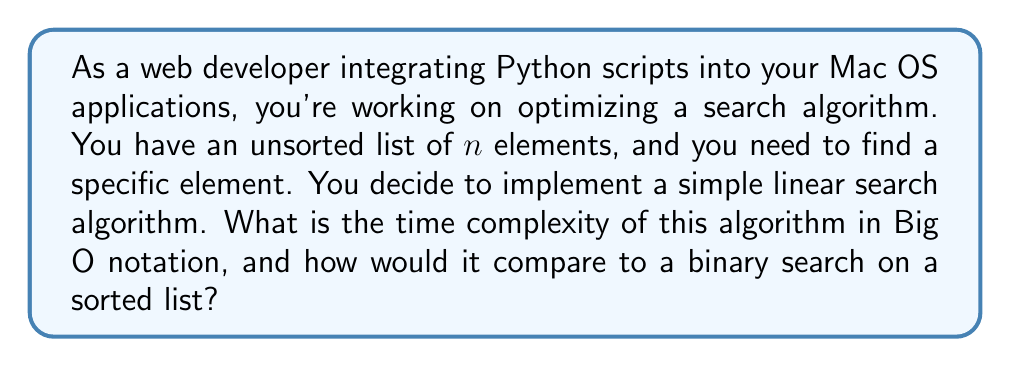Solve this math problem. To determine the time complexity of the linear search algorithm, let's break it down step-by-step:

1. Linear Search Algorithm:
   The linear search algorithm checks each element in the list sequentially until it finds the target element or reaches the end of the list.

2. Worst-case scenario:
   In the worst case, the element we're looking for is at the end of the list or not present at all. This means we need to check all $n$ elements.

3. Number of operations:
   For each element, we perform a constant-time comparison operation. So, the number of operations is directly proportional to the number of elements $n$.

4. Time Complexity:
   The time complexity is therefore $O(n)$, where $n$ is the number of elements in the list.

Comparison with Binary Search:
Binary search has a time complexity of $O(\log n)$, but it requires a sorted list. Here's a brief comparison:

$$
\begin{array}{|c|c|c|}
\hline
\text{Algorithm} & \text{Time Complexity} & \text{Requires Sorted List} \\
\hline
\text{Linear Search} & O(n) & \text{No} \\
\hline
\text{Binary Search} & O(\log n) & \text{Yes} \\
\hline
\end{array}
$$

For small lists or when the list is unsorted, linear search might be more practical. However, for large sorted lists, binary search is significantly more efficient.
Answer: The time complexity of the linear search algorithm is $O(n)$, where $n$ is the number of elements in the list. 